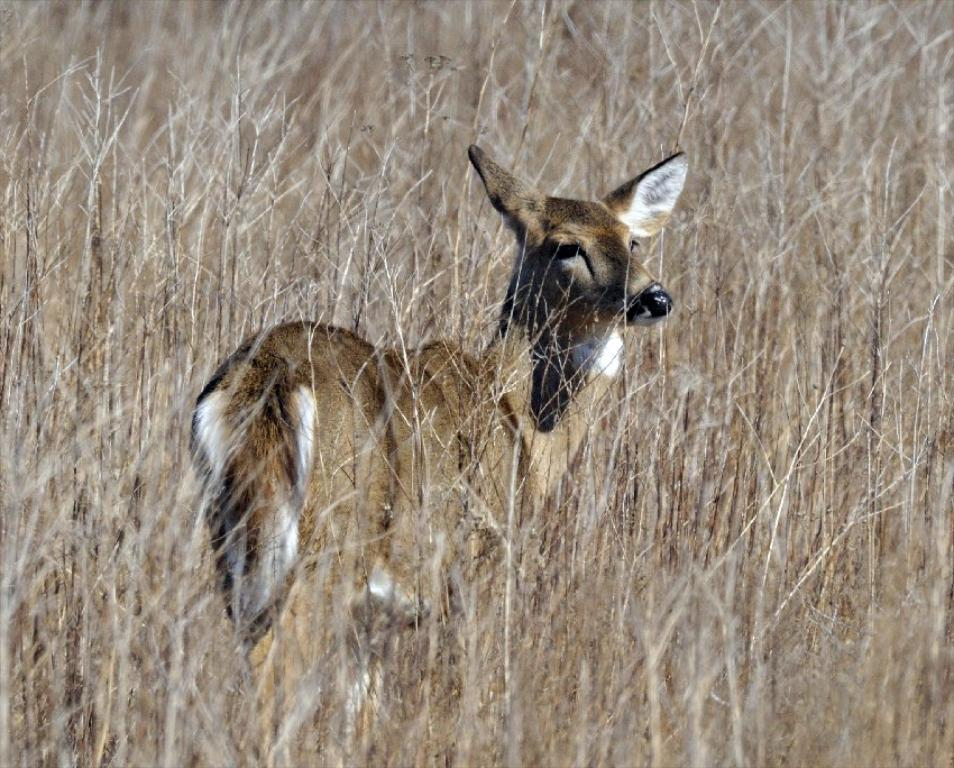What type of animal is in the image? The type of animal cannot be determined from the provided facts. What is the animal standing on or near in the image? The animal is standing on or near grass in the image. What type of police scene is depicted in the image? There is no police scene present in the image; it only features an animal and grass. 